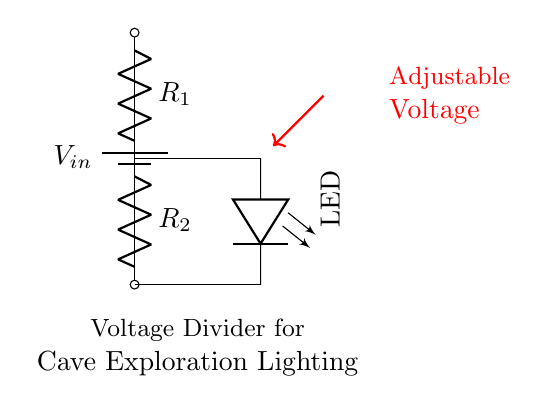What type of circuit configuration is shown? The circuit is a voltage divider, which consists of two resistors in series connected to a voltage source. This configuration allows the division of voltage across the components.
Answer: Voltage divider What components are present in the circuit? The circuit includes a battery, two resistors, and an LED. The battery provides the input voltage, while the resistors and LED are used for voltage division and lighting, respectively.
Answer: Battery, resistors, LED What is the purpose of the resistors in this circuit? The resistors in a voltage divider circuit are used to divide the input voltage into smaller output voltages, which can be used to power the LED at a safe operating voltage.
Answer: Divide voltage How are the resistors connected in this circuit? The resistors are connected in series, meaning the output voltage is measured across one of them (the second resistor) while the first resistor has the input voltage across it.
Answer: In series What voltage is needed for the LED to operate efficiently? Typically, an LED requires a forward voltage typically ranging from 2 to 3.5 volts, depending on the type; thus, the voltage output must be designed to meet this requirement.
Answer: 2-3.5 volts Why is the adjustable voltage indicated in the circuit? The adjustable voltage allows for varying the output voltage, which is crucial for different LED specifications or to ensure the LED can function optimally under changing conditions in cave exploration.
Answer: Adjustable voltage 